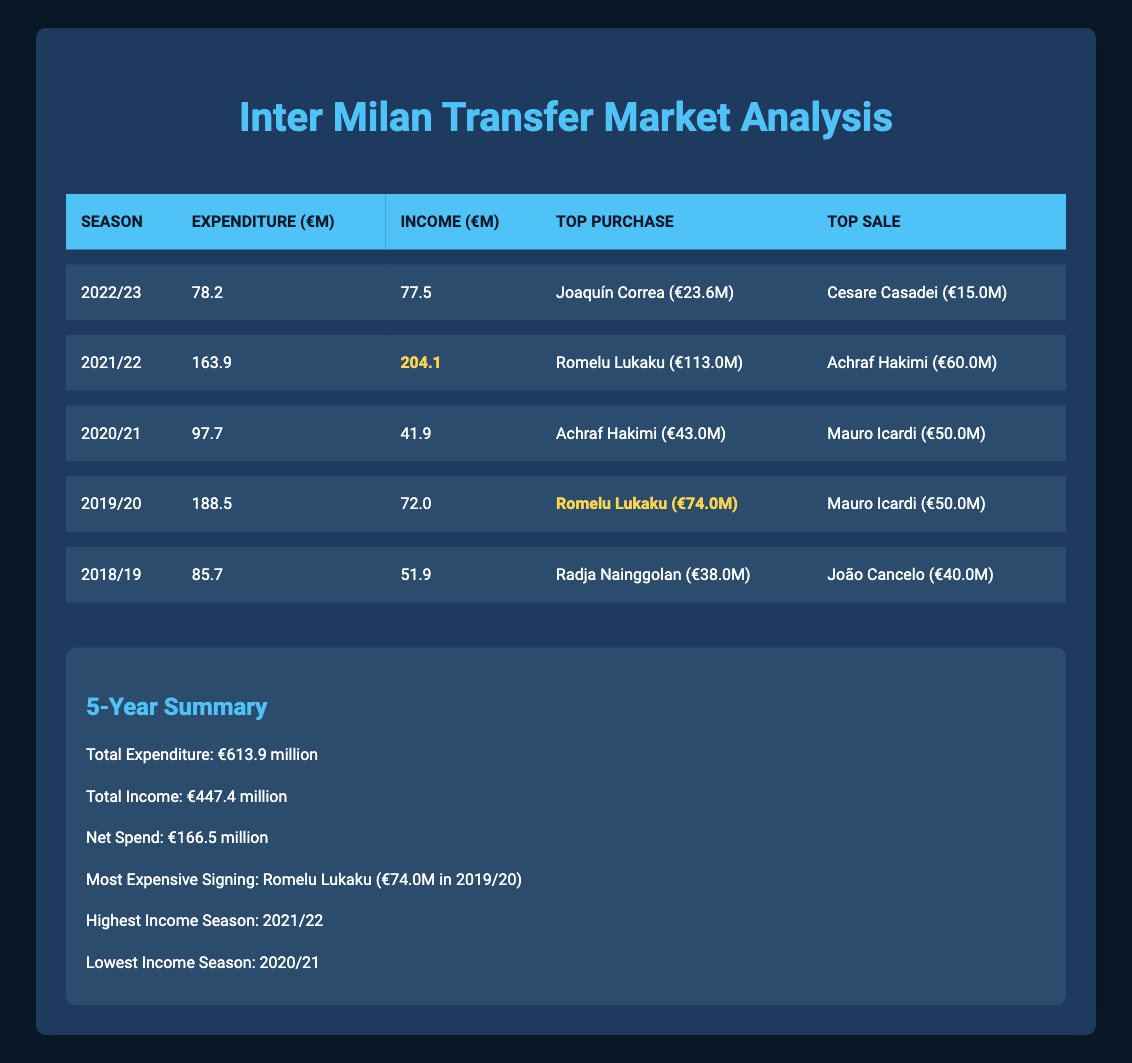What was Inter Milan's total transfer expenditure over the past 5 seasons? To find the total expenditure, we sum the expenditure values from each season: 78.2 + 163.9 + 97.7 + 188.5 + 85.7 = 613.9 million euros.
Answer: 613.9 million euros Which season had the highest income? From the table, we can see that the income value for 2021/22 is the highest at 204.1 million euros compared to other seasons.
Answer: 2021/22 What was the net spend for Inter Milan over the last 5 seasons? The net spend is calculated by subtracting total income from total expenditure: 613.9 - 447.4 = 166.5 million euros.
Answer: 166.5 million euros Was Romelu Lukaku the most expensive signing during the 2019/20 season? The table indicates that Romelu Lukaku was signed for 74.0 million euros, which is indeed the highest fee for any signing in that season, making this statement true.
Answer: Yes In how many seasons did Inter Milan's income exceed its expenditures? By looking at the income and expenditure for each season, it is clear that in only the 2021/22 season (204.1 income vs 163.9 expenditure) did income exceed expenditure.
Answer: 1 season What was the combined total of the top purchases made by Inter Milan in the last 5 seasons? We calculate the total of the top purchases: 23.6 (2022/23) + 113.0 (2021/22) + 43.0 (2020/21) + 74.0 (2019/20) + 38.0 (2018/19) = 290.6 million euros.
Answer: 290.6 million euros Which player was sold for the highest fee in the last 5 seasons? The table shows Achraf Hakimi was sold for 60.0 million euros in 2021/22, which is the highest amount compared to other sales listed.
Answer: Achraf Hakimi What is the average income per season for Inter Milan over the last 5 years? To find the average income, we sum the income values: 77.5 + 204.1 + 41.9 + 72.0 + 51.9 = 447.4 million euros, then divide by 5 (447.4/5 = 89.48).
Answer: 89.48 million euros How much more did Inter Milan spend in 2019/20 compared to 2020/21? We subtract the expenditure of 2020/21 from that of 2019/20: 188.5 - 97.7 = 90.8 million euros.
Answer: 90.8 million euros 